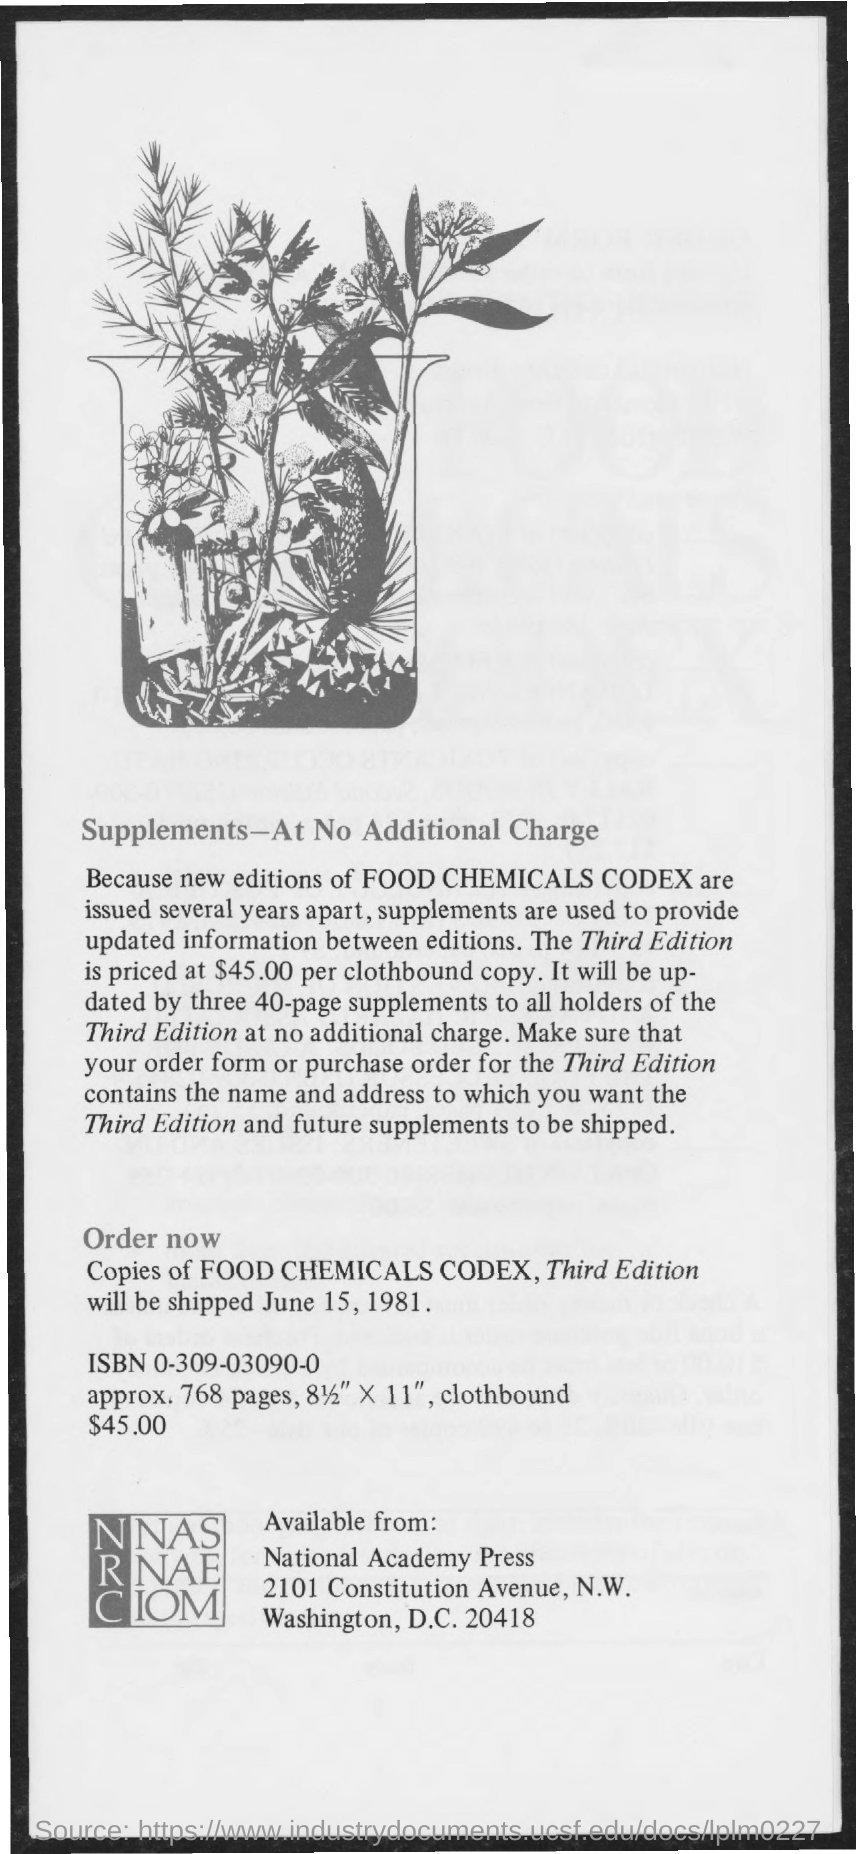What is the third edition priced at?
Offer a very short reply. $45.00 per clothbound copy. When will it be shipped?
Ensure brevity in your answer.  June 15, 1981. 